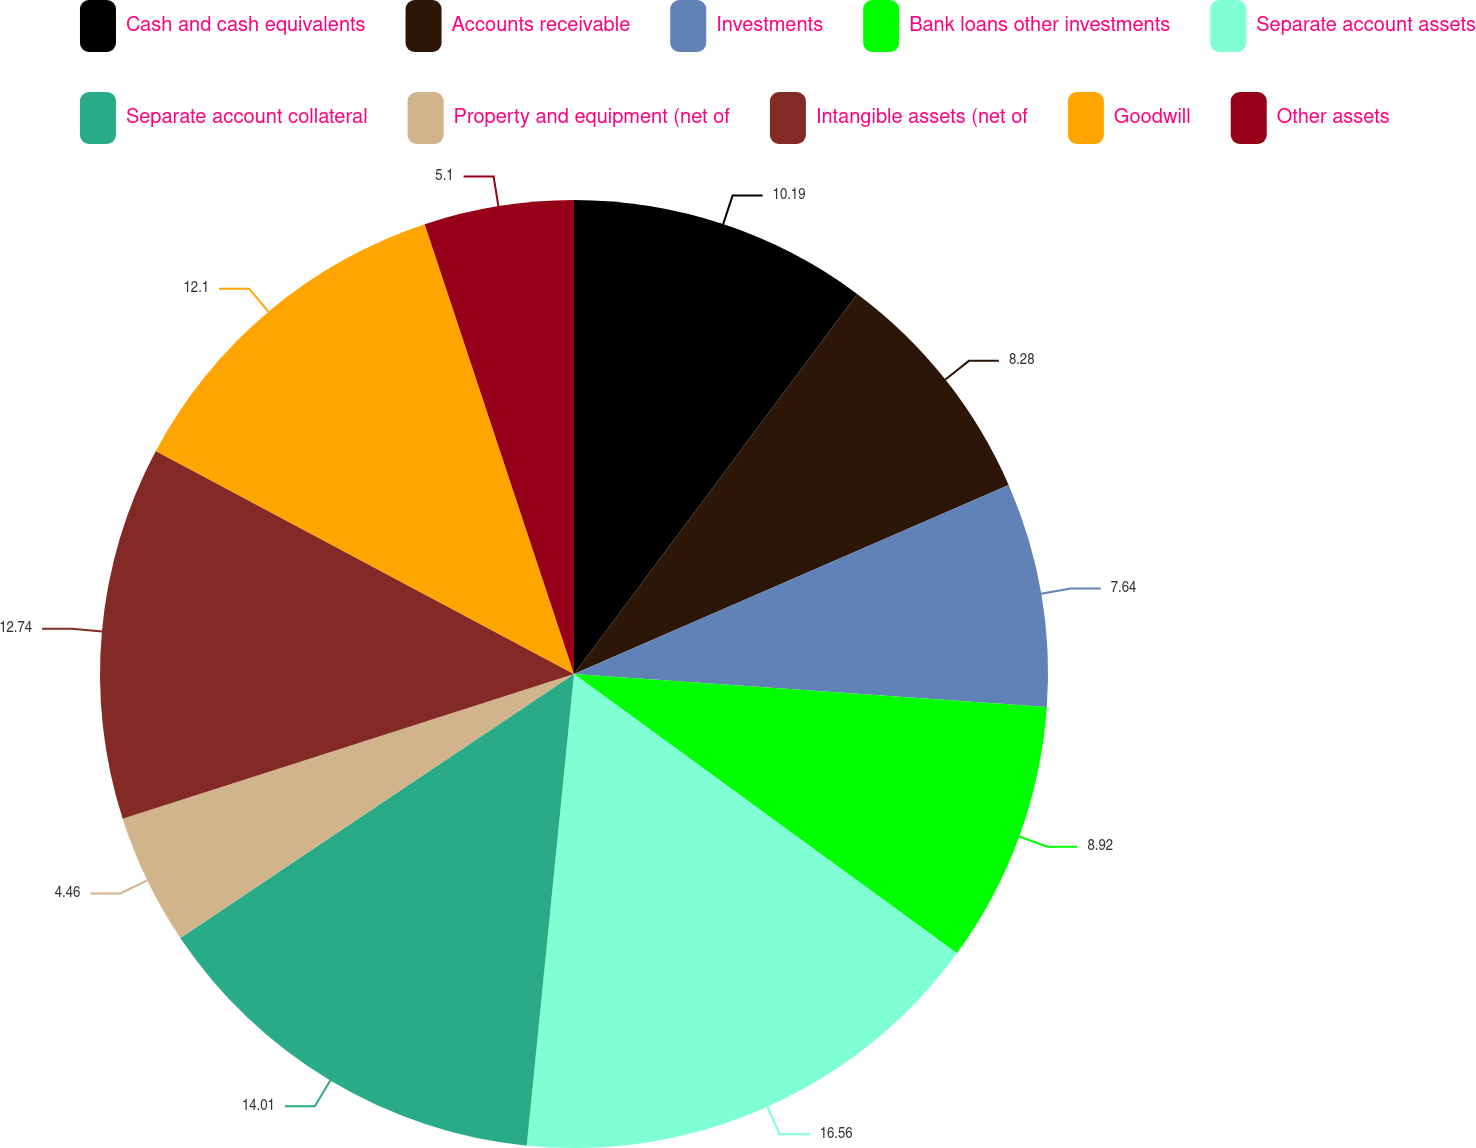<chart> <loc_0><loc_0><loc_500><loc_500><pie_chart><fcel>Cash and cash equivalents<fcel>Accounts receivable<fcel>Investments<fcel>Bank loans other investments<fcel>Separate account assets<fcel>Separate account collateral<fcel>Property and equipment (net of<fcel>Intangible assets (net of<fcel>Goodwill<fcel>Other assets<nl><fcel>10.19%<fcel>8.28%<fcel>7.64%<fcel>8.92%<fcel>16.56%<fcel>14.01%<fcel>4.46%<fcel>12.74%<fcel>12.1%<fcel>5.1%<nl></chart> 